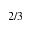<formula> <loc_0><loc_0><loc_500><loc_500>2 / 3</formula> 